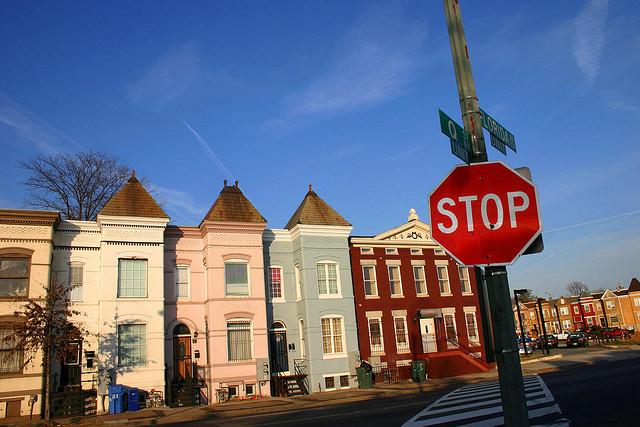What color is the house centered between two others?
Keep it brief. Pink. Is the red stop sign sitting under a blue sky?
Answer briefly. Yes. What does the red sign say to do?
Answer briefly. Stop. 